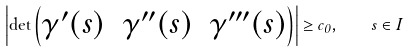Convert formula to latex. <formula><loc_0><loc_0><loc_500><loc_500>\left | \det \begin{pmatrix} \gamma ^ { \prime } ( s ) & \gamma ^ { \prime \prime } ( s ) & \gamma ^ { \prime \prime \prime } ( s ) \end{pmatrix} \right | \geq c _ { 0 } , \quad s \in I</formula> 